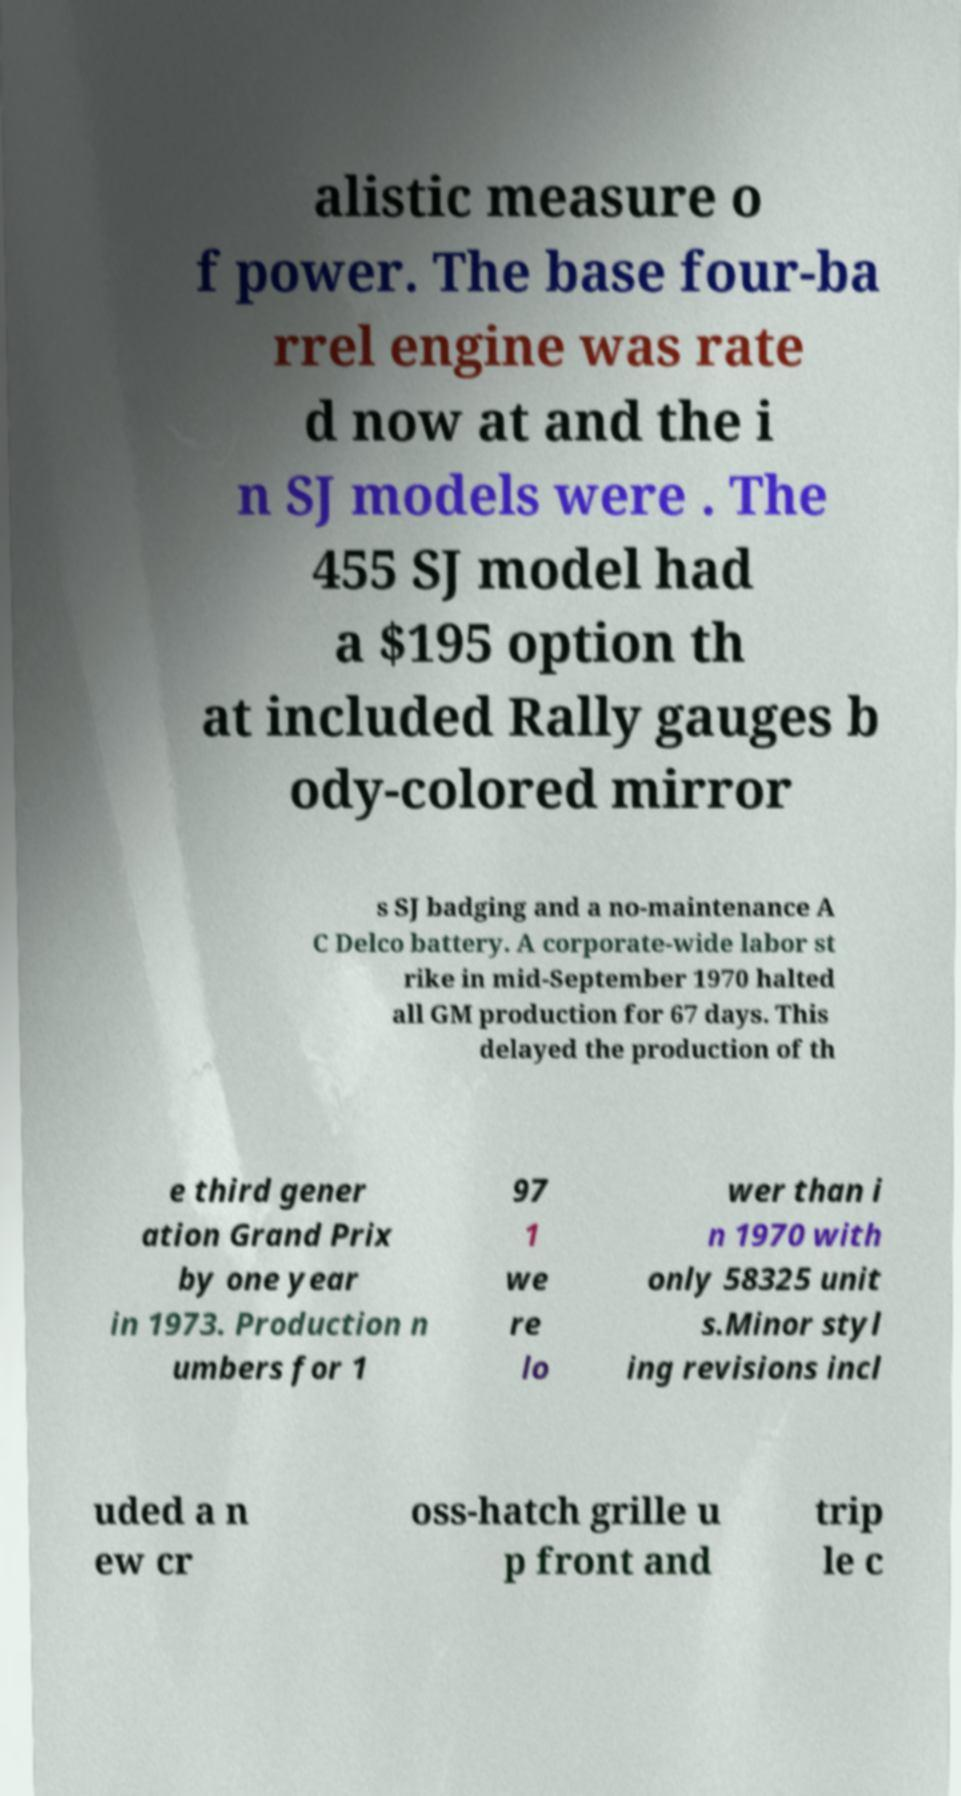Could you assist in decoding the text presented in this image and type it out clearly? alistic measure o f power. The base four-ba rrel engine was rate d now at and the i n SJ models were . The 455 SJ model had a $195 option th at included Rally gauges b ody-colored mirror s SJ badging and a no-maintenance A C Delco battery. A corporate-wide labor st rike in mid-September 1970 halted all GM production for 67 days. This delayed the production of th e third gener ation Grand Prix by one year in 1973. Production n umbers for 1 97 1 we re lo wer than i n 1970 with only 58325 unit s.Minor styl ing revisions incl uded a n ew cr oss-hatch grille u p front and trip le c 